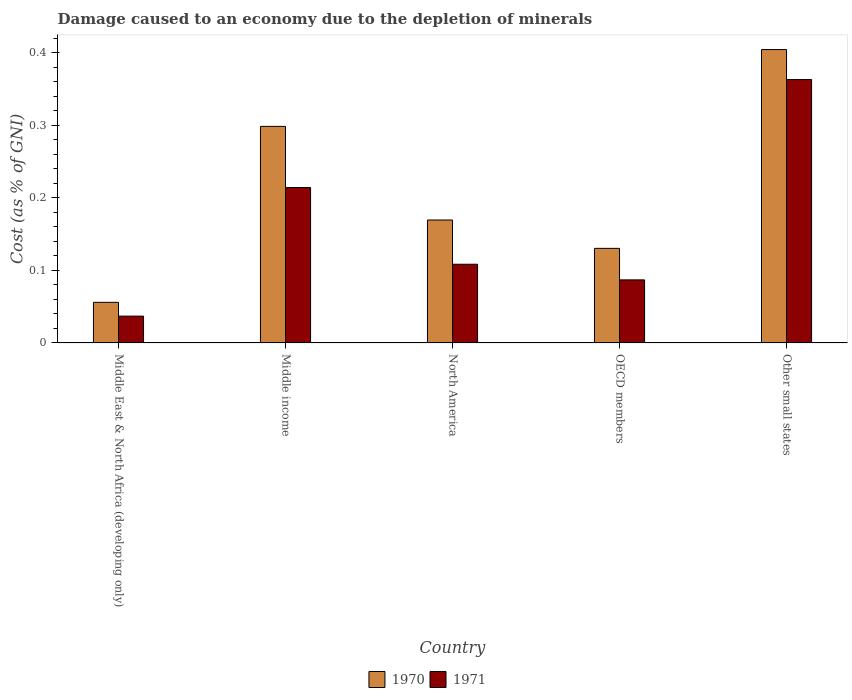How many groups of bars are there?
Make the answer very short. 5. How many bars are there on the 4th tick from the left?
Make the answer very short. 2. What is the label of the 3rd group of bars from the left?
Keep it short and to the point. North America. What is the cost of damage caused due to the depletion of minerals in 1970 in Middle East & North Africa (developing only)?
Keep it short and to the point. 0.06. Across all countries, what is the maximum cost of damage caused due to the depletion of minerals in 1970?
Your answer should be compact. 0.4. Across all countries, what is the minimum cost of damage caused due to the depletion of minerals in 1970?
Offer a very short reply. 0.06. In which country was the cost of damage caused due to the depletion of minerals in 1971 maximum?
Provide a short and direct response. Other small states. In which country was the cost of damage caused due to the depletion of minerals in 1970 minimum?
Your answer should be very brief. Middle East & North Africa (developing only). What is the total cost of damage caused due to the depletion of minerals in 1971 in the graph?
Your answer should be compact. 0.81. What is the difference between the cost of damage caused due to the depletion of minerals in 1971 in North America and that in Other small states?
Make the answer very short. -0.25. What is the difference between the cost of damage caused due to the depletion of minerals in 1971 in Middle income and the cost of damage caused due to the depletion of minerals in 1970 in OECD members?
Give a very brief answer. 0.08. What is the average cost of damage caused due to the depletion of minerals in 1971 per country?
Make the answer very short. 0.16. What is the difference between the cost of damage caused due to the depletion of minerals of/in 1971 and cost of damage caused due to the depletion of minerals of/in 1970 in Middle income?
Offer a terse response. -0.08. What is the ratio of the cost of damage caused due to the depletion of minerals in 1971 in Middle income to that in OECD members?
Keep it short and to the point. 2.46. What is the difference between the highest and the second highest cost of damage caused due to the depletion of minerals in 1971?
Your response must be concise. 0.25. What is the difference between the highest and the lowest cost of damage caused due to the depletion of minerals in 1971?
Offer a very short reply. 0.33. In how many countries, is the cost of damage caused due to the depletion of minerals in 1971 greater than the average cost of damage caused due to the depletion of minerals in 1971 taken over all countries?
Ensure brevity in your answer.  2. Is the sum of the cost of damage caused due to the depletion of minerals in 1971 in Middle East & North Africa (developing only) and North America greater than the maximum cost of damage caused due to the depletion of minerals in 1970 across all countries?
Ensure brevity in your answer.  No. How many bars are there?
Provide a short and direct response. 10. How many countries are there in the graph?
Your response must be concise. 5. Does the graph contain any zero values?
Offer a terse response. No. Where does the legend appear in the graph?
Keep it short and to the point. Bottom center. How are the legend labels stacked?
Your answer should be very brief. Horizontal. What is the title of the graph?
Make the answer very short. Damage caused to an economy due to the depletion of minerals. What is the label or title of the Y-axis?
Offer a terse response. Cost (as % of GNI). What is the Cost (as % of GNI) of 1970 in Middle East & North Africa (developing only)?
Offer a very short reply. 0.06. What is the Cost (as % of GNI) of 1971 in Middle East & North Africa (developing only)?
Ensure brevity in your answer.  0.04. What is the Cost (as % of GNI) of 1970 in Middle income?
Offer a very short reply. 0.3. What is the Cost (as % of GNI) of 1971 in Middle income?
Give a very brief answer. 0.21. What is the Cost (as % of GNI) in 1970 in North America?
Your answer should be very brief. 0.17. What is the Cost (as % of GNI) of 1971 in North America?
Ensure brevity in your answer.  0.11. What is the Cost (as % of GNI) in 1970 in OECD members?
Ensure brevity in your answer.  0.13. What is the Cost (as % of GNI) in 1971 in OECD members?
Your answer should be very brief. 0.09. What is the Cost (as % of GNI) in 1970 in Other small states?
Offer a terse response. 0.4. What is the Cost (as % of GNI) in 1971 in Other small states?
Make the answer very short. 0.36. Across all countries, what is the maximum Cost (as % of GNI) of 1970?
Ensure brevity in your answer.  0.4. Across all countries, what is the maximum Cost (as % of GNI) in 1971?
Provide a succinct answer. 0.36. Across all countries, what is the minimum Cost (as % of GNI) in 1970?
Offer a terse response. 0.06. Across all countries, what is the minimum Cost (as % of GNI) in 1971?
Provide a short and direct response. 0.04. What is the total Cost (as % of GNI) of 1970 in the graph?
Give a very brief answer. 1.06. What is the total Cost (as % of GNI) in 1971 in the graph?
Keep it short and to the point. 0.81. What is the difference between the Cost (as % of GNI) in 1970 in Middle East & North Africa (developing only) and that in Middle income?
Give a very brief answer. -0.24. What is the difference between the Cost (as % of GNI) of 1971 in Middle East & North Africa (developing only) and that in Middle income?
Make the answer very short. -0.18. What is the difference between the Cost (as % of GNI) in 1970 in Middle East & North Africa (developing only) and that in North America?
Ensure brevity in your answer.  -0.11. What is the difference between the Cost (as % of GNI) of 1971 in Middle East & North Africa (developing only) and that in North America?
Give a very brief answer. -0.07. What is the difference between the Cost (as % of GNI) in 1970 in Middle East & North Africa (developing only) and that in OECD members?
Offer a very short reply. -0.07. What is the difference between the Cost (as % of GNI) of 1971 in Middle East & North Africa (developing only) and that in OECD members?
Your response must be concise. -0.05. What is the difference between the Cost (as % of GNI) of 1970 in Middle East & North Africa (developing only) and that in Other small states?
Offer a terse response. -0.35. What is the difference between the Cost (as % of GNI) in 1971 in Middle East & North Africa (developing only) and that in Other small states?
Your answer should be very brief. -0.33. What is the difference between the Cost (as % of GNI) in 1970 in Middle income and that in North America?
Give a very brief answer. 0.13. What is the difference between the Cost (as % of GNI) in 1971 in Middle income and that in North America?
Your answer should be very brief. 0.11. What is the difference between the Cost (as % of GNI) in 1970 in Middle income and that in OECD members?
Provide a succinct answer. 0.17. What is the difference between the Cost (as % of GNI) in 1971 in Middle income and that in OECD members?
Your answer should be compact. 0.13. What is the difference between the Cost (as % of GNI) in 1970 in Middle income and that in Other small states?
Provide a short and direct response. -0.11. What is the difference between the Cost (as % of GNI) in 1971 in Middle income and that in Other small states?
Provide a succinct answer. -0.15. What is the difference between the Cost (as % of GNI) in 1970 in North America and that in OECD members?
Offer a very short reply. 0.04. What is the difference between the Cost (as % of GNI) of 1971 in North America and that in OECD members?
Your answer should be very brief. 0.02. What is the difference between the Cost (as % of GNI) in 1970 in North America and that in Other small states?
Your answer should be compact. -0.23. What is the difference between the Cost (as % of GNI) of 1971 in North America and that in Other small states?
Your response must be concise. -0.25. What is the difference between the Cost (as % of GNI) of 1970 in OECD members and that in Other small states?
Your answer should be very brief. -0.27. What is the difference between the Cost (as % of GNI) of 1971 in OECD members and that in Other small states?
Provide a short and direct response. -0.28. What is the difference between the Cost (as % of GNI) in 1970 in Middle East & North Africa (developing only) and the Cost (as % of GNI) in 1971 in Middle income?
Make the answer very short. -0.16. What is the difference between the Cost (as % of GNI) of 1970 in Middle East & North Africa (developing only) and the Cost (as % of GNI) of 1971 in North America?
Your answer should be very brief. -0.05. What is the difference between the Cost (as % of GNI) in 1970 in Middle East & North Africa (developing only) and the Cost (as % of GNI) in 1971 in OECD members?
Make the answer very short. -0.03. What is the difference between the Cost (as % of GNI) of 1970 in Middle East & North Africa (developing only) and the Cost (as % of GNI) of 1971 in Other small states?
Your response must be concise. -0.31. What is the difference between the Cost (as % of GNI) in 1970 in Middle income and the Cost (as % of GNI) in 1971 in North America?
Your response must be concise. 0.19. What is the difference between the Cost (as % of GNI) of 1970 in Middle income and the Cost (as % of GNI) of 1971 in OECD members?
Ensure brevity in your answer.  0.21. What is the difference between the Cost (as % of GNI) of 1970 in Middle income and the Cost (as % of GNI) of 1971 in Other small states?
Give a very brief answer. -0.06. What is the difference between the Cost (as % of GNI) of 1970 in North America and the Cost (as % of GNI) of 1971 in OECD members?
Make the answer very short. 0.08. What is the difference between the Cost (as % of GNI) of 1970 in North America and the Cost (as % of GNI) of 1971 in Other small states?
Give a very brief answer. -0.19. What is the difference between the Cost (as % of GNI) of 1970 in OECD members and the Cost (as % of GNI) of 1971 in Other small states?
Offer a very short reply. -0.23. What is the average Cost (as % of GNI) in 1970 per country?
Offer a terse response. 0.21. What is the average Cost (as % of GNI) in 1971 per country?
Your answer should be very brief. 0.16. What is the difference between the Cost (as % of GNI) in 1970 and Cost (as % of GNI) in 1971 in Middle East & North Africa (developing only)?
Provide a succinct answer. 0.02. What is the difference between the Cost (as % of GNI) of 1970 and Cost (as % of GNI) of 1971 in Middle income?
Provide a short and direct response. 0.08. What is the difference between the Cost (as % of GNI) in 1970 and Cost (as % of GNI) in 1971 in North America?
Keep it short and to the point. 0.06. What is the difference between the Cost (as % of GNI) of 1970 and Cost (as % of GNI) of 1971 in OECD members?
Offer a very short reply. 0.04. What is the difference between the Cost (as % of GNI) of 1970 and Cost (as % of GNI) of 1971 in Other small states?
Your response must be concise. 0.04. What is the ratio of the Cost (as % of GNI) of 1970 in Middle East & North Africa (developing only) to that in Middle income?
Offer a terse response. 0.19. What is the ratio of the Cost (as % of GNI) of 1971 in Middle East & North Africa (developing only) to that in Middle income?
Your answer should be very brief. 0.17. What is the ratio of the Cost (as % of GNI) of 1970 in Middle East & North Africa (developing only) to that in North America?
Offer a very short reply. 0.33. What is the ratio of the Cost (as % of GNI) of 1971 in Middle East & North Africa (developing only) to that in North America?
Make the answer very short. 0.34. What is the ratio of the Cost (as % of GNI) of 1970 in Middle East & North Africa (developing only) to that in OECD members?
Keep it short and to the point. 0.43. What is the ratio of the Cost (as % of GNI) in 1971 in Middle East & North Africa (developing only) to that in OECD members?
Give a very brief answer. 0.43. What is the ratio of the Cost (as % of GNI) in 1970 in Middle East & North Africa (developing only) to that in Other small states?
Make the answer very short. 0.14. What is the ratio of the Cost (as % of GNI) in 1971 in Middle East & North Africa (developing only) to that in Other small states?
Give a very brief answer. 0.1. What is the ratio of the Cost (as % of GNI) of 1970 in Middle income to that in North America?
Your answer should be very brief. 1.76. What is the ratio of the Cost (as % of GNI) in 1971 in Middle income to that in North America?
Keep it short and to the point. 1.97. What is the ratio of the Cost (as % of GNI) of 1970 in Middle income to that in OECD members?
Make the answer very short. 2.29. What is the ratio of the Cost (as % of GNI) in 1971 in Middle income to that in OECD members?
Keep it short and to the point. 2.46. What is the ratio of the Cost (as % of GNI) in 1970 in Middle income to that in Other small states?
Give a very brief answer. 0.74. What is the ratio of the Cost (as % of GNI) in 1971 in Middle income to that in Other small states?
Provide a short and direct response. 0.59. What is the ratio of the Cost (as % of GNI) of 1970 in North America to that in OECD members?
Your answer should be very brief. 1.3. What is the ratio of the Cost (as % of GNI) of 1971 in North America to that in OECD members?
Your answer should be compact. 1.25. What is the ratio of the Cost (as % of GNI) in 1970 in North America to that in Other small states?
Give a very brief answer. 0.42. What is the ratio of the Cost (as % of GNI) of 1971 in North America to that in Other small states?
Your response must be concise. 0.3. What is the ratio of the Cost (as % of GNI) in 1970 in OECD members to that in Other small states?
Your response must be concise. 0.32. What is the ratio of the Cost (as % of GNI) in 1971 in OECD members to that in Other small states?
Make the answer very short. 0.24. What is the difference between the highest and the second highest Cost (as % of GNI) of 1970?
Your answer should be very brief. 0.11. What is the difference between the highest and the second highest Cost (as % of GNI) of 1971?
Your response must be concise. 0.15. What is the difference between the highest and the lowest Cost (as % of GNI) of 1970?
Give a very brief answer. 0.35. What is the difference between the highest and the lowest Cost (as % of GNI) in 1971?
Provide a short and direct response. 0.33. 